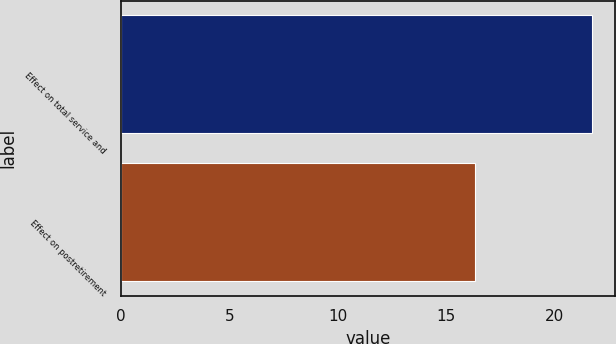Convert chart to OTSL. <chart><loc_0><loc_0><loc_500><loc_500><bar_chart><fcel>Effect on total service and<fcel>Effect on postretirement<nl><fcel>21.7<fcel>16.3<nl></chart> 